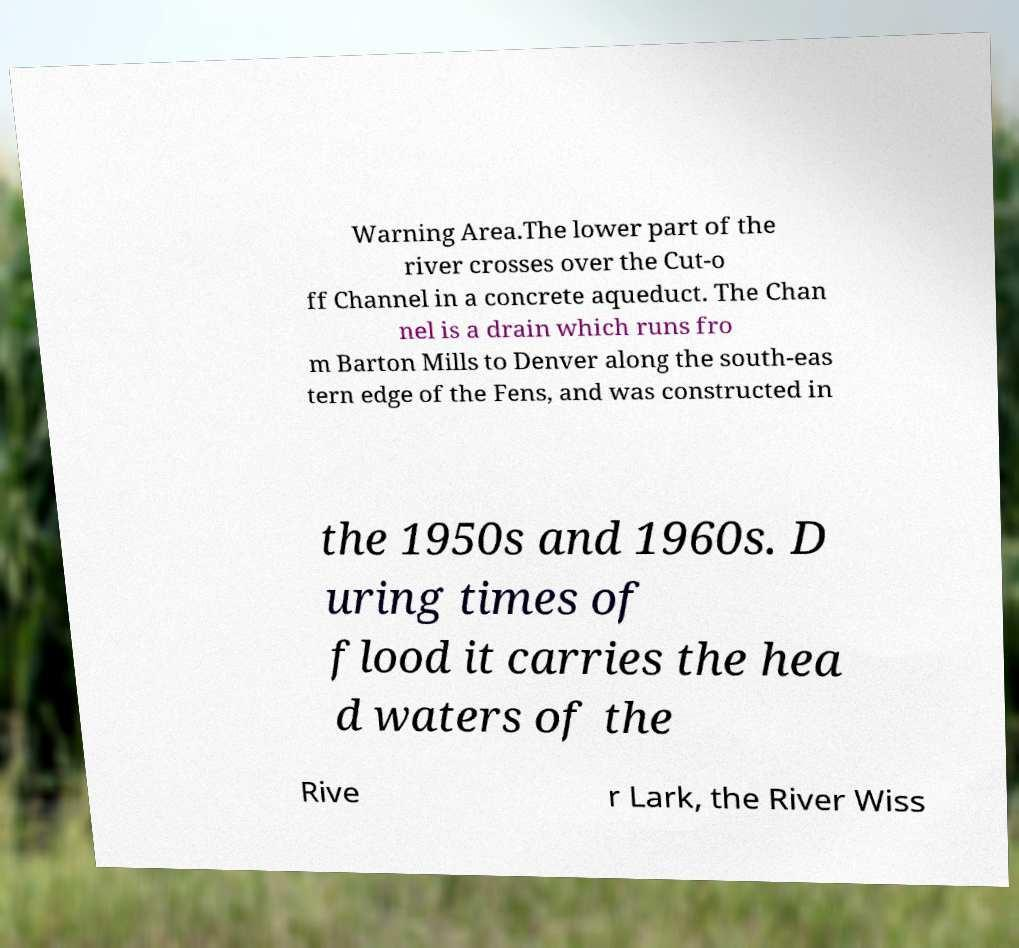Could you assist in decoding the text presented in this image and type it out clearly? Warning Area.The lower part of the river crosses over the Cut-o ff Channel in a concrete aqueduct. The Chan nel is a drain which runs fro m Barton Mills to Denver along the south-eas tern edge of the Fens, and was constructed in the 1950s and 1960s. D uring times of flood it carries the hea d waters of the Rive r Lark, the River Wiss 